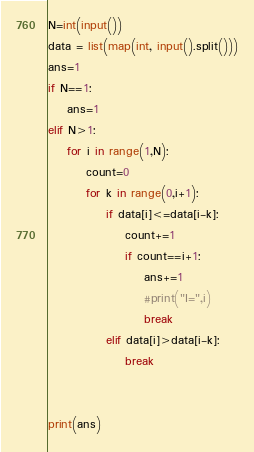<code> <loc_0><loc_0><loc_500><loc_500><_Python_>N=int(input())
data = list(map(int, input().split()))
ans=1
if N==1:
    ans=1
elif N>1:
    for i in range(1,N):
        count=0
        for k in range(0,i+1):
            if data[i]<=data[i-k]:
                count+=1
                if count==i+1:
                    ans+=1
                    #print("I=",i)
                    break
            elif data[i]>data[i-k]:
                break


print(ans)</code> 